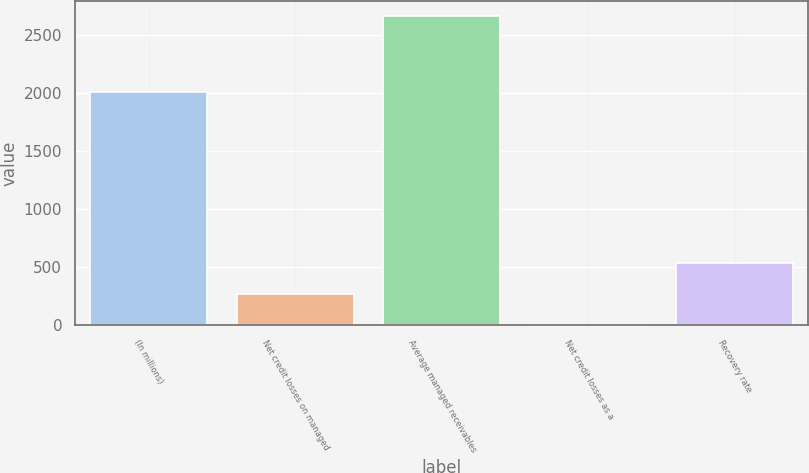Convert chart to OTSL. <chart><loc_0><loc_0><loc_500><loc_500><bar_chart><fcel>(In millions)<fcel>Net credit losses on managed<fcel>Average managed receivables<fcel>Net credit losses as a<fcel>Recovery rate<nl><fcel>2006<fcel>266.39<fcel>2657.7<fcel>0.69<fcel>532.09<nl></chart> 